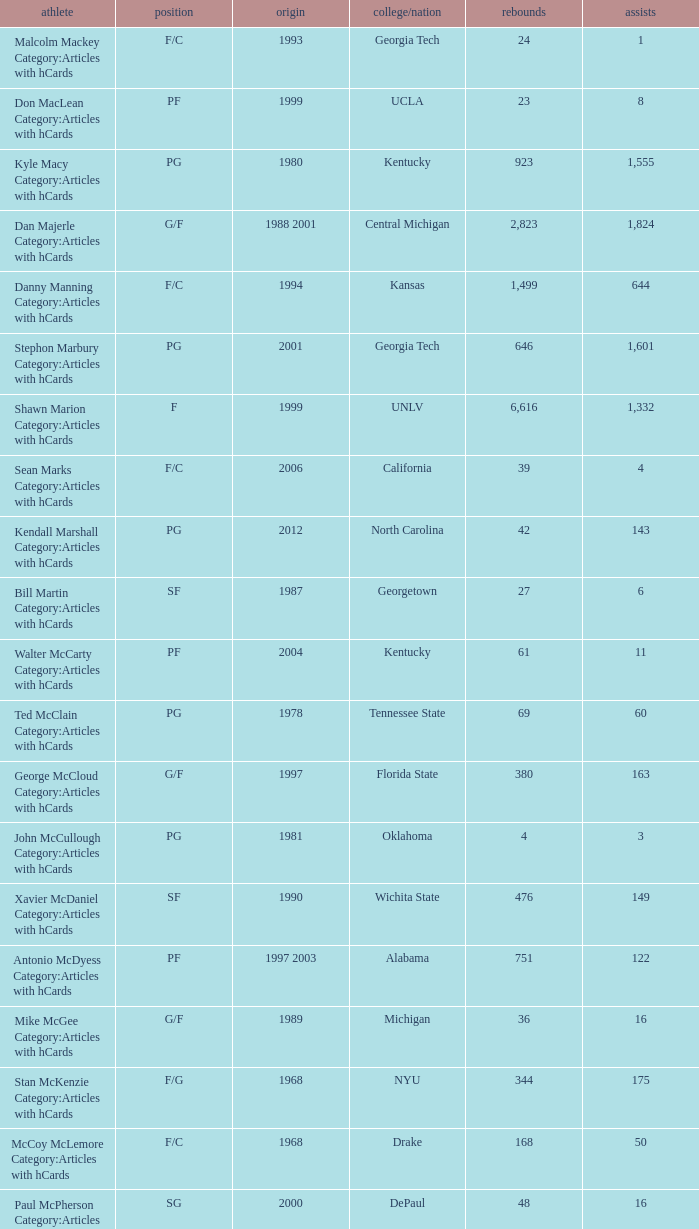What position does the player from arkansas play? C. 